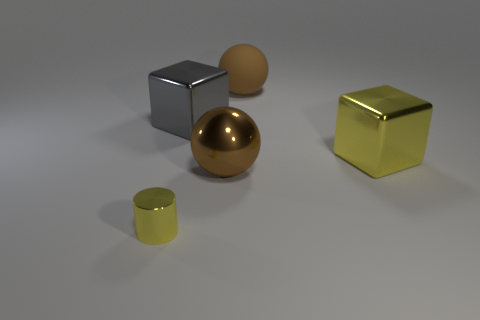Add 2 large shiny blocks. How many objects exist? 7 Subtract all spheres. How many objects are left? 3 Subtract 0 purple spheres. How many objects are left? 5 Subtract all large brown things. Subtract all big balls. How many objects are left? 1 Add 2 big brown matte objects. How many big brown matte objects are left? 3 Add 2 purple cubes. How many purple cubes exist? 2 